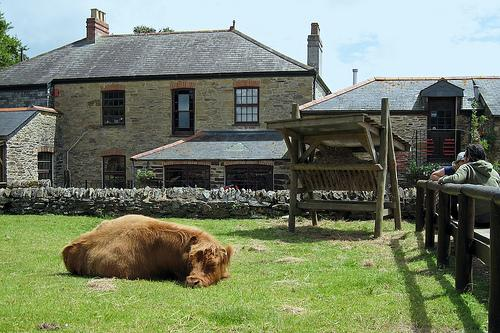Analyze the interaction between the cow and its surroundings in the image. The cow is calmly sleeping in the grass, surrounded by a peaceful environment with a stone house in the background and people conversing by a wooden fence nearby. What is the color of the sky in the image and what does this indicate about the weather? The sky is blue and clear, which implies a sunny and pleasant weather. Identify the object in the image where animals might eat from and describe its material. There is a wooden feeding trough in the image, which could be used for animals to eat from. What are the two main elements of the image's background and what are they made of? The background mainly features a large stone house and a stone fence around the back garden. In the image, what building is made of stone and located behind the field? A large stone house with a two-car garage, two sets of chimneys on the roof, and a long rectangular middle window is situated behind the field. What type of animal is occupying the majority of the image and what is its current state? The image predominantly features a brown cow, which appears to be sleeping in the grass. Describe the conversation happening in the image between the two individuals. Two people are standing by a fence, engaged in a conversation, possibly discussing the brown cow that's sleeping in the grass. Count the number of cows in the image and describe the main activity they are involved in. There is one cow in the image, and it is sleeping in the grass. Provide a short caption for the image. "Peaceful afternoon: Brown cow sleeping in the grass while two people converse by the fence." From the image, what is the quality and condition of the grass in the field? The grass in the field is light green and seems to be eaten, probably by the cow sleeping in it. 